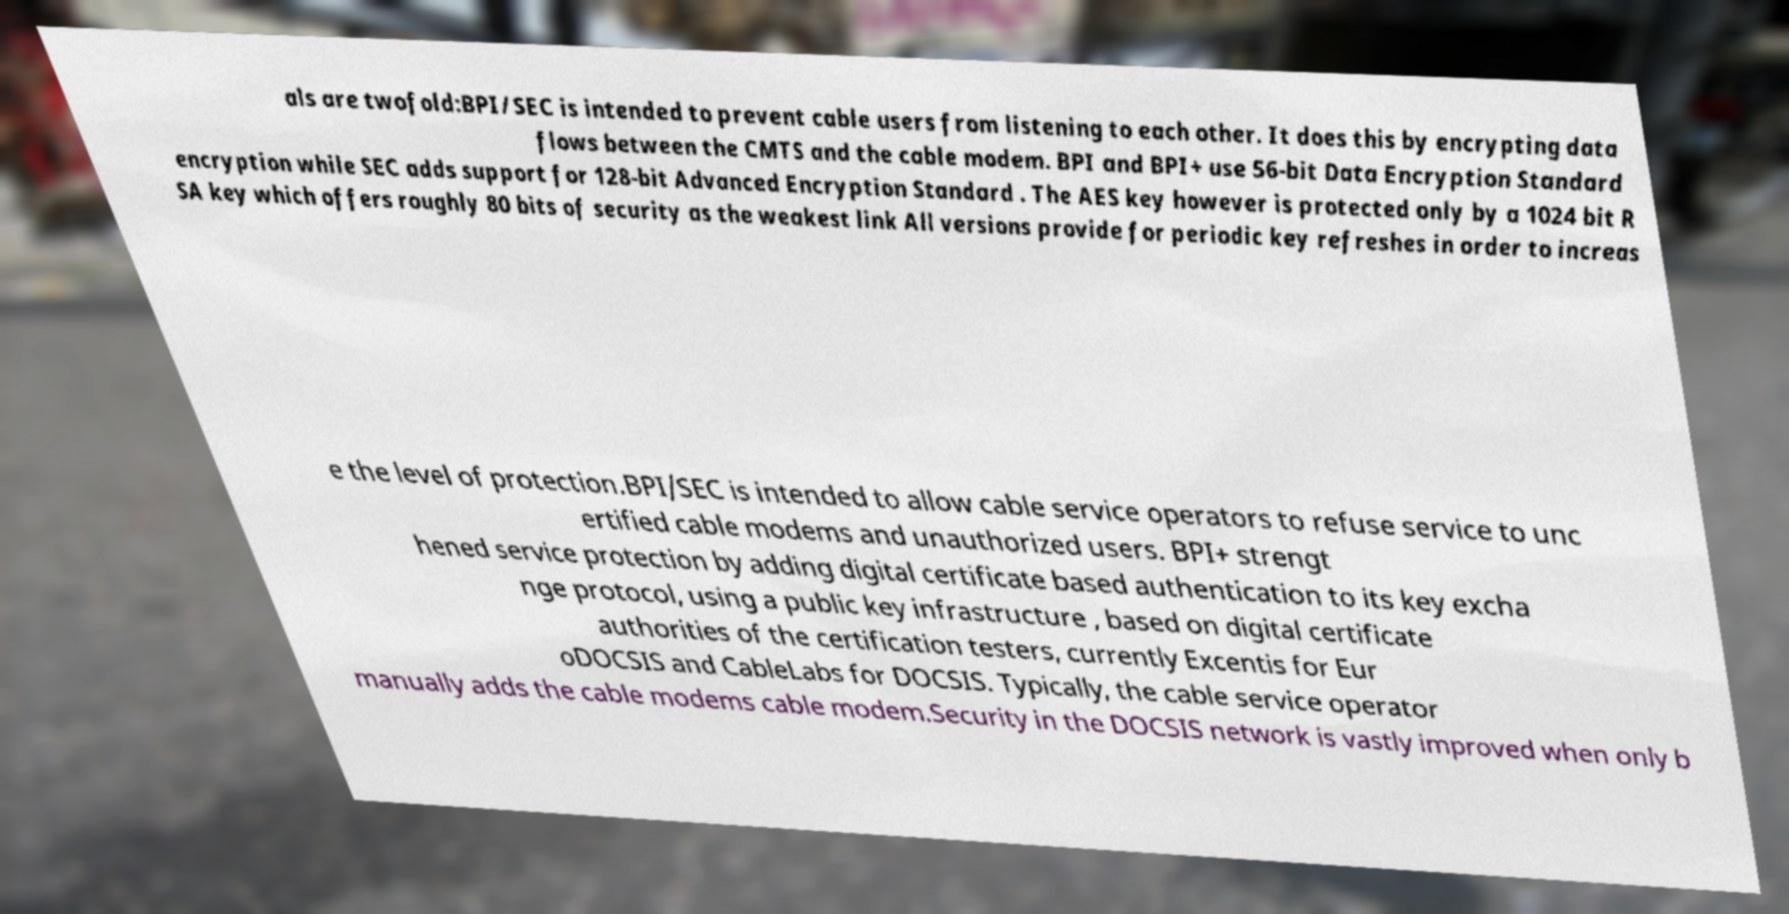Please read and relay the text visible in this image. What does it say? als are twofold:BPI/SEC is intended to prevent cable users from listening to each other. It does this by encrypting data flows between the CMTS and the cable modem. BPI and BPI+ use 56-bit Data Encryption Standard encryption while SEC adds support for 128-bit Advanced Encryption Standard . The AES key however is protected only by a 1024 bit R SA key which offers roughly 80 bits of security as the weakest link All versions provide for periodic key refreshes in order to increas e the level of protection.BPI/SEC is intended to allow cable service operators to refuse service to unc ertified cable modems and unauthorized users. BPI+ strengt hened service protection by adding digital certificate based authentication to its key excha nge protocol, using a public key infrastructure , based on digital certificate authorities of the certification testers, currently Excentis for Eur oDOCSIS and CableLabs for DOCSIS. Typically, the cable service operator manually adds the cable modems cable modem.Security in the DOCSIS network is vastly improved when only b 